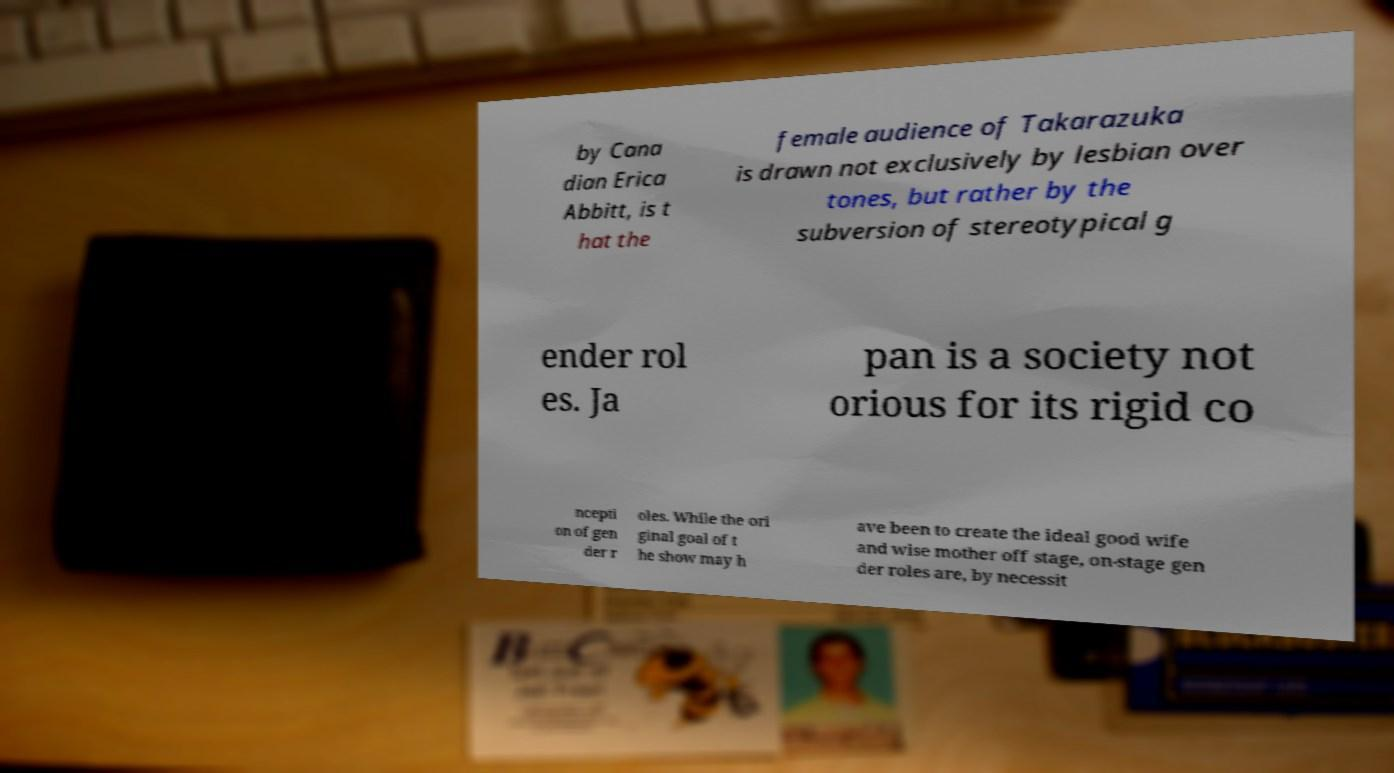Could you extract and type out the text from this image? by Cana dian Erica Abbitt, is t hat the female audience of Takarazuka is drawn not exclusively by lesbian over tones, but rather by the subversion of stereotypical g ender rol es. Ja pan is a society not orious for its rigid co ncepti on of gen der r oles. While the ori ginal goal of t he show may h ave been to create the ideal good wife and wise mother off stage, on-stage gen der roles are, by necessit 